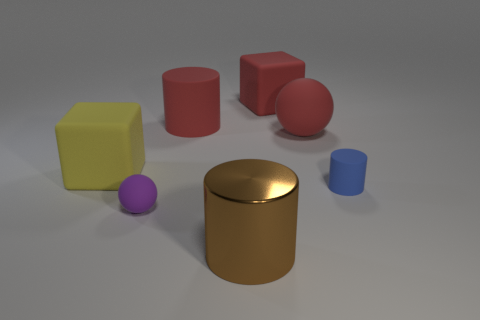There is a big red matte thing that is to the left of the brown metallic cylinder; is its shape the same as the matte thing to the left of the tiny rubber ball?
Your response must be concise. No. Are there any other things that are the same color as the metal object?
Offer a very short reply. No. There is a purple object that is the same material as the big yellow object; what is its shape?
Provide a succinct answer. Sphere. There is a cylinder that is behind the large brown metal cylinder and left of the tiny blue rubber cylinder; what is its material?
Your response must be concise. Rubber. Is the color of the tiny ball the same as the large metallic cylinder?
Give a very brief answer. No. What number of purple matte objects are the same shape as the metallic object?
Offer a terse response. 0. The blue object that is made of the same material as the big yellow cube is what size?
Your response must be concise. Small. Do the yellow rubber block and the purple ball have the same size?
Your answer should be compact. No. Are there any big objects?
Make the answer very short. Yes. There is a block that is behind the matte cylinder to the left of the rubber cylinder to the right of the large red block; how big is it?
Your answer should be very brief. Large. 